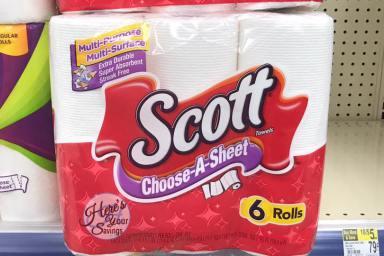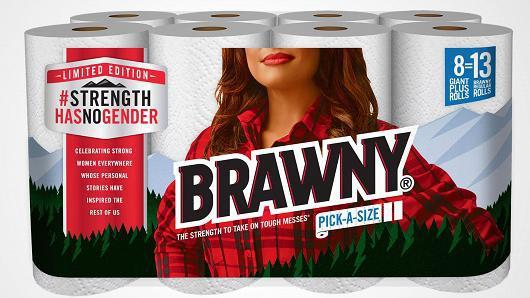The first image is the image on the left, the second image is the image on the right. For the images displayed, is the sentence "At least one package is stacked on another in the image on the left." factually correct? Answer yes or no. No. The first image is the image on the left, the second image is the image on the right. For the images displayed, is the sentence "A multi-pack of paper towel rolls shows a woman in a red plaid shirt on the package front." factually correct? Answer yes or no. Yes. 